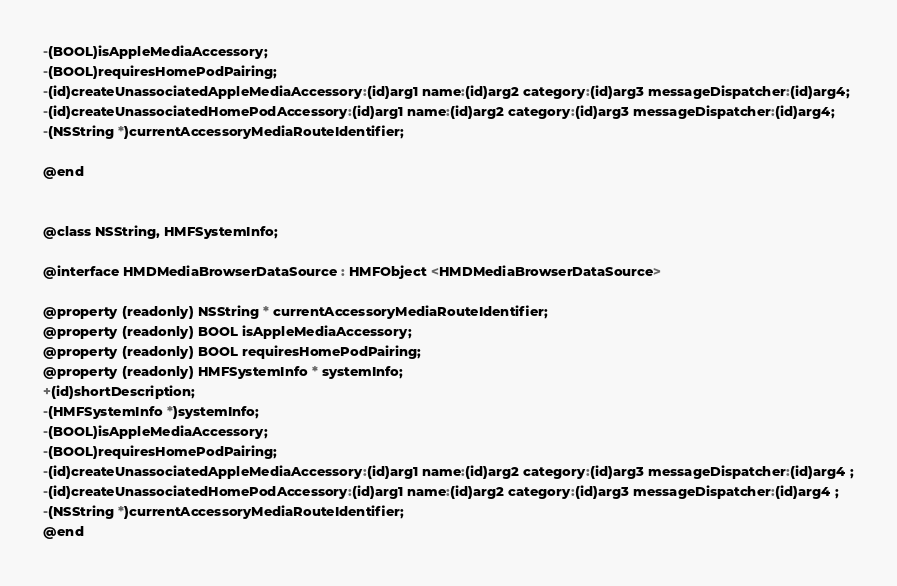<code> <loc_0><loc_0><loc_500><loc_500><_C_>-(BOOL)isAppleMediaAccessory;
-(BOOL)requiresHomePodPairing;
-(id)createUnassociatedAppleMediaAccessory:(id)arg1 name:(id)arg2 category:(id)arg3 messageDispatcher:(id)arg4;
-(id)createUnassociatedHomePodAccessory:(id)arg1 name:(id)arg2 category:(id)arg3 messageDispatcher:(id)arg4;
-(NSString *)currentAccessoryMediaRouteIdentifier;

@end


@class NSString, HMFSystemInfo;

@interface HMDMediaBrowserDataSource : HMFObject <HMDMediaBrowserDataSource>

@property (readonly) NSString * currentAccessoryMediaRouteIdentifier; 
@property (readonly) BOOL isAppleMediaAccessory; 
@property (readonly) BOOL requiresHomePodPairing; 
@property (readonly) HMFSystemInfo * systemInfo; 
+(id)shortDescription;
-(HMFSystemInfo *)systemInfo;
-(BOOL)isAppleMediaAccessory;
-(BOOL)requiresHomePodPairing;
-(id)createUnassociatedAppleMediaAccessory:(id)arg1 name:(id)arg2 category:(id)arg3 messageDispatcher:(id)arg4 ;
-(id)createUnassociatedHomePodAccessory:(id)arg1 name:(id)arg2 category:(id)arg3 messageDispatcher:(id)arg4 ;
-(NSString *)currentAccessoryMediaRouteIdentifier;
@end

</code> 